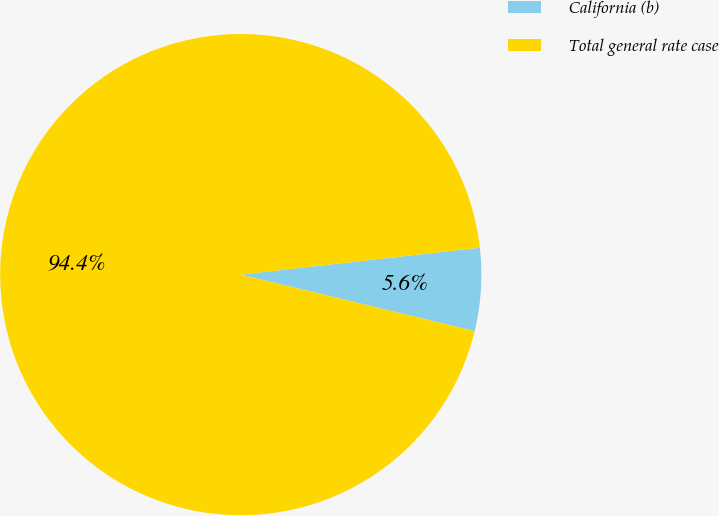Convert chart to OTSL. <chart><loc_0><loc_0><loc_500><loc_500><pie_chart><fcel>California (b)<fcel>Total general rate case<nl><fcel>5.56%<fcel>94.44%<nl></chart> 